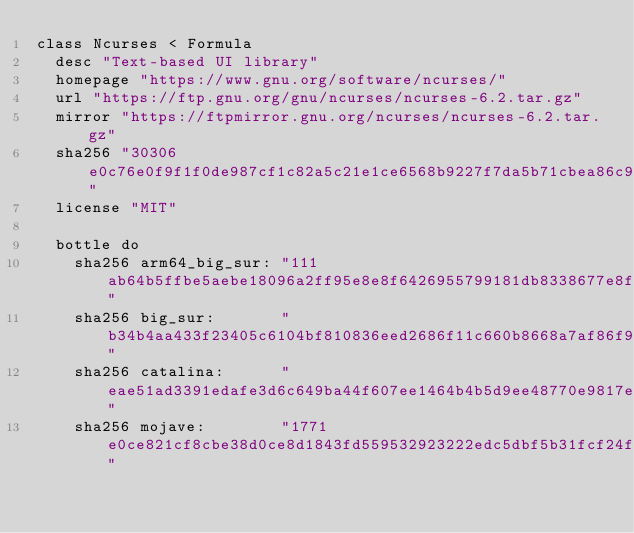<code> <loc_0><loc_0><loc_500><loc_500><_Ruby_>class Ncurses < Formula
  desc "Text-based UI library"
  homepage "https://www.gnu.org/software/ncurses/"
  url "https://ftp.gnu.org/gnu/ncurses/ncurses-6.2.tar.gz"
  mirror "https://ftpmirror.gnu.org/ncurses/ncurses-6.2.tar.gz"
  sha256 "30306e0c76e0f9f1f0de987cf1c82a5c21e1ce6568b9227f7da5b71cbea86c9d"
  license "MIT"

  bottle do
    sha256 arm64_big_sur: "111ab64b5ffbe5aebe18096a2ff95e8e8f6426955799181db8338677e8f853e4"
    sha256 big_sur:       "b34b4aa433f23405c6104bf810836eed2686f11c660b8668a7af86f99be2329f"
    sha256 catalina:      "eae51ad3391edafe3d6c649ba44f607ee1464b4b5d9ee48770e9817ee5f0ccdd"
    sha256 mojave:        "1771e0ce821cf8cbe38d0ce8d1843fd559532923222edc5dbf5b31fcf24fed90"</code> 